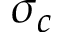<formula> <loc_0><loc_0><loc_500><loc_500>\sigma _ { c }</formula> 